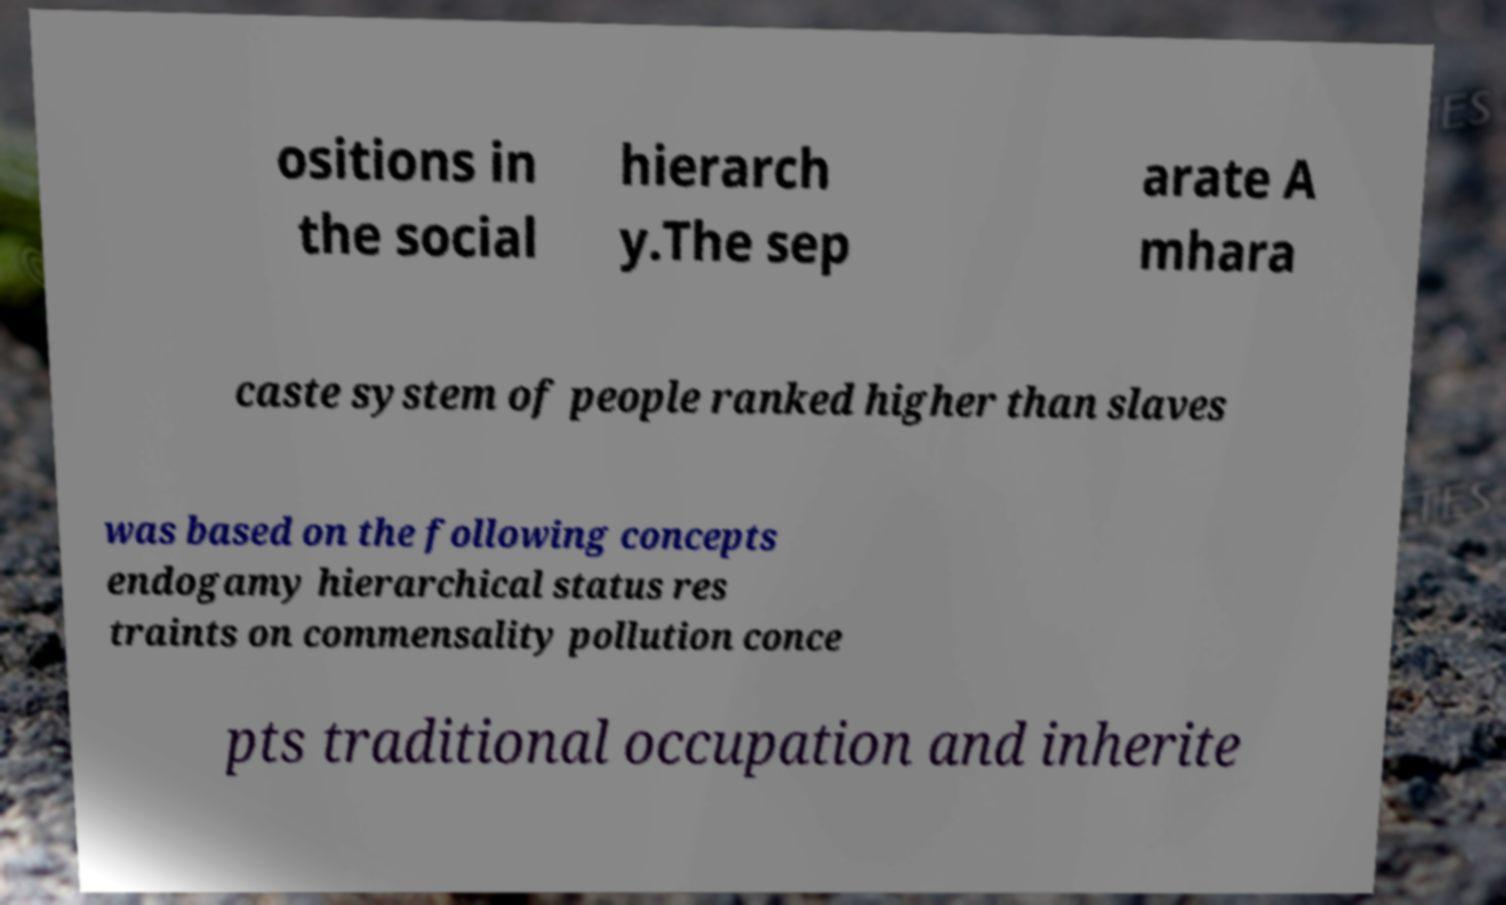Could you assist in decoding the text presented in this image and type it out clearly? ositions in the social hierarch y.The sep arate A mhara caste system of people ranked higher than slaves was based on the following concepts endogamy hierarchical status res traints on commensality pollution conce pts traditional occupation and inherite 